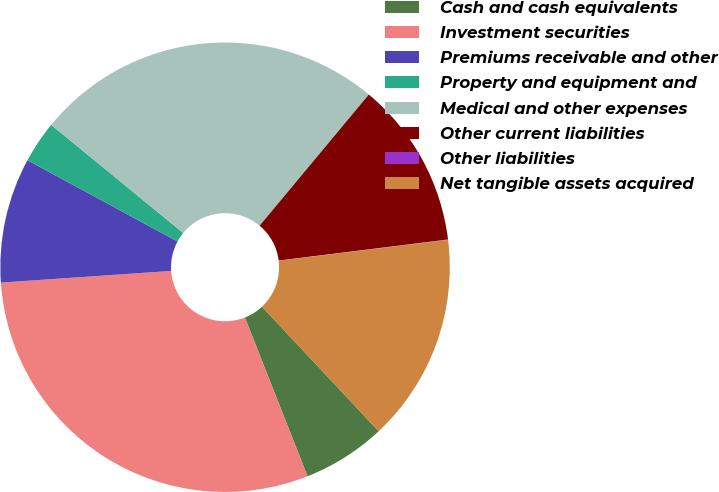Convert chart to OTSL. <chart><loc_0><loc_0><loc_500><loc_500><pie_chart><fcel>Cash and cash equivalents<fcel>Investment securities<fcel>Premiums receivable and other<fcel>Property and equipment and<fcel>Medical and other expenses<fcel>Other current liabilities<fcel>Other liabilities<fcel>Net tangible assets acquired<nl><fcel>6.0%<fcel>29.89%<fcel>8.99%<fcel>3.02%<fcel>25.13%<fcel>11.98%<fcel>0.03%<fcel>14.96%<nl></chart> 